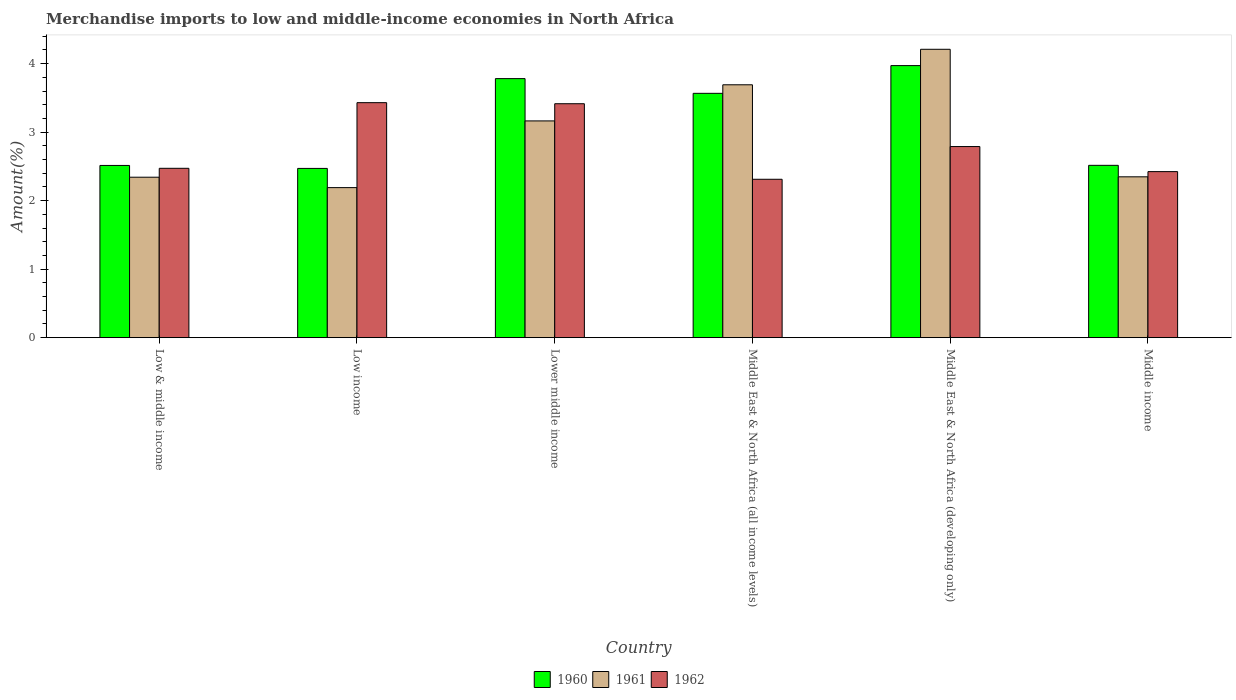Are the number of bars on each tick of the X-axis equal?
Ensure brevity in your answer.  Yes. What is the label of the 2nd group of bars from the left?
Your answer should be compact. Low income. In how many cases, is the number of bars for a given country not equal to the number of legend labels?
Provide a succinct answer. 0. What is the percentage of amount earned from merchandise imports in 1962 in Low income?
Offer a terse response. 3.43. Across all countries, what is the maximum percentage of amount earned from merchandise imports in 1960?
Offer a terse response. 3.97. Across all countries, what is the minimum percentage of amount earned from merchandise imports in 1962?
Give a very brief answer. 2.31. In which country was the percentage of amount earned from merchandise imports in 1960 maximum?
Provide a succinct answer. Middle East & North Africa (developing only). In which country was the percentage of amount earned from merchandise imports in 1962 minimum?
Keep it short and to the point. Middle East & North Africa (all income levels). What is the total percentage of amount earned from merchandise imports in 1962 in the graph?
Provide a short and direct response. 16.84. What is the difference between the percentage of amount earned from merchandise imports in 1960 in Middle East & North Africa (developing only) and that in Middle income?
Give a very brief answer. 1.46. What is the difference between the percentage of amount earned from merchandise imports in 1962 in Low & middle income and the percentage of amount earned from merchandise imports in 1961 in Middle income?
Offer a terse response. 0.12. What is the average percentage of amount earned from merchandise imports in 1962 per country?
Your answer should be very brief. 2.81. What is the difference between the percentage of amount earned from merchandise imports of/in 1961 and percentage of amount earned from merchandise imports of/in 1962 in Middle East & North Africa (developing only)?
Offer a terse response. 1.42. What is the ratio of the percentage of amount earned from merchandise imports in 1961 in Low & middle income to that in Middle East & North Africa (all income levels)?
Your answer should be very brief. 0.63. Is the difference between the percentage of amount earned from merchandise imports in 1961 in Low income and Lower middle income greater than the difference between the percentage of amount earned from merchandise imports in 1962 in Low income and Lower middle income?
Offer a terse response. No. What is the difference between the highest and the second highest percentage of amount earned from merchandise imports in 1960?
Offer a very short reply. -0.19. What is the difference between the highest and the lowest percentage of amount earned from merchandise imports in 1960?
Provide a succinct answer. 1.5. Are all the bars in the graph horizontal?
Provide a short and direct response. No. What is the difference between two consecutive major ticks on the Y-axis?
Your response must be concise. 1. How are the legend labels stacked?
Your answer should be very brief. Horizontal. What is the title of the graph?
Make the answer very short. Merchandise imports to low and middle-income economies in North Africa. Does "2000" appear as one of the legend labels in the graph?
Offer a very short reply. No. What is the label or title of the X-axis?
Make the answer very short. Country. What is the label or title of the Y-axis?
Your answer should be very brief. Amount(%). What is the Amount(%) in 1960 in Low & middle income?
Make the answer very short. 2.51. What is the Amount(%) in 1961 in Low & middle income?
Offer a very short reply. 2.34. What is the Amount(%) of 1962 in Low & middle income?
Your response must be concise. 2.47. What is the Amount(%) in 1960 in Low income?
Offer a terse response. 2.47. What is the Amount(%) of 1961 in Low income?
Keep it short and to the point. 2.19. What is the Amount(%) in 1962 in Low income?
Your answer should be very brief. 3.43. What is the Amount(%) of 1960 in Lower middle income?
Offer a very short reply. 3.78. What is the Amount(%) of 1961 in Lower middle income?
Provide a succinct answer. 3.16. What is the Amount(%) in 1962 in Lower middle income?
Make the answer very short. 3.41. What is the Amount(%) in 1960 in Middle East & North Africa (all income levels)?
Offer a very short reply. 3.57. What is the Amount(%) of 1961 in Middle East & North Africa (all income levels)?
Provide a succinct answer. 3.69. What is the Amount(%) in 1962 in Middle East & North Africa (all income levels)?
Give a very brief answer. 2.31. What is the Amount(%) of 1960 in Middle East & North Africa (developing only)?
Offer a very short reply. 3.97. What is the Amount(%) of 1961 in Middle East & North Africa (developing only)?
Provide a short and direct response. 4.21. What is the Amount(%) of 1962 in Middle East & North Africa (developing only)?
Your response must be concise. 2.79. What is the Amount(%) in 1960 in Middle income?
Provide a succinct answer. 2.52. What is the Amount(%) of 1961 in Middle income?
Make the answer very short. 2.35. What is the Amount(%) in 1962 in Middle income?
Give a very brief answer. 2.42. Across all countries, what is the maximum Amount(%) in 1960?
Offer a terse response. 3.97. Across all countries, what is the maximum Amount(%) in 1961?
Provide a succinct answer. 4.21. Across all countries, what is the maximum Amount(%) of 1962?
Make the answer very short. 3.43. Across all countries, what is the minimum Amount(%) of 1960?
Your answer should be compact. 2.47. Across all countries, what is the minimum Amount(%) of 1961?
Keep it short and to the point. 2.19. Across all countries, what is the minimum Amount(%) in 1962?
Offer a very short reply. 2.31. What is the total Amount(%) in 1960 in the graph?
Make the answer very short. 18.82. What is the total Amount(%) in 1961 in the graph?
Offer a terse response. 17.94. What is the total Amount(%) of 1962 in the graph?
Make the answer very short. 16.84. What is the difference between the Amount(%) of 1960 in Low & middle income and that in Low income?
Offer a very short reply. 0.04. What is the difference between the Amount(%) in 1961 in Low & middle income and that in Low income?
Your response must be concise. 0.15. What is the difference between the Amount(%) in 1962 in Low & middle income and that in Low income?
Make the answer very short. -0.96. What is the difference between the Amount(%) in 1960 in Low & middle income and that in Lower middle income?
Make the answer very short. -1.27. What is the difference between the Amount(%) of 1961 in Low & middle income and that in Lower middle income?
Offer a very short reply. -0.82. What is the difference between the Amount(%) in 1962 in Low & middle income and that in Lower middle income?
Make the answer very short. -0.94. What is the difference between the Amount(%) in 1960 in Low & middle income and that in Middle East & North Africa (all income levels)?
Provide a short and direct response. -1.05. What is the difference between the Amount(%) in 1961 in Low & middle income and that in Middle East & North Africa (all income levels)?
Your answer should be compact. -1.35. What is the difference between the Amount(%) of 1962 in Low & middle income and that in Middle East & North Africa (all income levels)?
Offer a terse response. 0.16. What is the difference between the Amount(%) in 1960 in Low & middle income and that in Middle East & North Africa (developing only)?
Your answer should be compact. -1.46. What is the difference between the Amount(%) in 1961 in Low & middle income and that in Middle East & North Africa (developing only)?
Offer a terse response. -1.87. What is the difference between the Amount(%) of 1962 in Low & middle income and that in Middle East & North Africa (developing only)?
Offer a terse response. -0.32. What is the difference between the Amount(%) of 1960 in Low & middle income and that in Middle income?
Ensure brevity in your answer.  -0. What is the difference between the Amount(%) in 1961 in Low & middle income and that in Middle income?
Give a very brief answer. -0.01. What is the difference between the Amount(%) of 1962 in Low & middle income and that in Middle income?
Your answer should be compact. 0.05. What is the difference between the Amount(%) in 1960 in Low income and that in Lower middle income?
Provide a short and direct response. -1.31. What is the difference between the Amount(%) of 1961 in Low income and that in Lower middle income?
Offer a very short reply. -0.97. What is the difference between the Amount(%) of 1962 in Low income and that in Lower middle income?
Ensure brevity in your answer.  0.02. What is the difference between the Amount(%) in 1960 in Low income and that in Middle East & North Africa (all income levels)?
Provide a short and direct response. -1.1. What is the difference between the Amount(%) in 1961 in Low income and that in Middle East & North Africa (all income levels)?
Ensure brevity in your answer.  -1.5. What is the difference between the Amount(%) of 1962 in Low income and that in Middle East & North Africa (all income levels)?
Offer a very short reply. 1.12. What is the difference between the Amount(%) of 1960 in Low income and that in Middle East & North Africa (developing only)?
Your answer should be very brief. -1.5. What is the difference between the Amount(%) in 1961 in Low income and that in Middle East & North Africa (developing only)?
Ensure brevity in your answer.  -2.02. What is the difference between the Amount(%) in 1962 in Low income and that in Middle East & North Africa (developing only)?
Give a very brief answer. 0.64. What is the difference between the Amount(%) in 1960 in Low income and that in Middle income?
Your answer should be very brief. -0.04. What is the difference between the Amount(%) in 1961 in Low income and that in Middle income?
Offer a terse response. -0.16. What is the difference between the Amount(%) of 1962 in Low income and that in Middle income?
Your answer should be compact. 1.01. What is the difference between the Amount(%) of 1960 in Lower middle income and that in Middle East & North Africa (all income levels)?
Your answer should be very brief. 0.21. What is the difference between the Amount(%) in 1961 in Lower middle income and that in Middle East & North Africa (all income levels)?
Ensure brevity in your answer.  -0.53. What is the difference between the Amount(%) in 1962 in Lower middle income and that in Middle East & North Africa (all income levels)?
Your response must be concise. 1.1. What is the difference between the Amount(%) of 1960 in Lower middle income and that in Middle East & North Africa (developing only)?
Your answer should be compact. -0.19. What is the difference between the Amount(%) in 1961 in Lower middle income and that in Middle East & North Africa (developing only)?
Provide a short and direct response. -1.05. What is the difference between the Amount(%) of 1962 in Lower middle income and that in Middle East & North Africa (developing only)?
Your answer should be very brief. 0.63. What is the difference between the Amount(%) in 1960 in Lower middle income and that in Middle income?
Your response must be concise. 1.27. What is the difference between the Amount(%) of 1961 in Lower middle income and that in Middle income?
Make the answer very short. 0.82. What is the difference between the Amount(%) in 1962 in Lower middle income and that in Middle income?
Your answer should be compact. 0.99. What is the difference between the Amount(%) of 1960 in Middle East & North Africa (all income levels) and that in Middle East & North Africa (developing only)?
Your answer should be very brief. -0.4. What is the difference between the Amount(%) in 1961 in Middle East & North Africa (all income levels) and that in Middle East & North Africa (developing only)?
Keep it short and to the point. -0.52. What is the difference between the Amount(%) of 1962 in Middle East & North Africa (all income levels) and that in Middle East & North Africa (developing only)?
Offer a very short reply. -0.48. What is the difference between the Amount(%) in 1960 in Middle East & North Africa (all income levels) and that in Middle income?
Provide a short and direct response. 1.05. What is the difference between the Amount(%) in 1961 in Middle East & North Africa (all income levels) and that in Middle income?
Give a very brief answer. 1.34. What is the difference between the Amount(%) of 1962 in Middle East & North Africa (all income levels) and that in Middle income?
Keep it short and to the point. -0.11. What is the difference between the Amount(%) in 1960 in Middle East & North Africa (developing only) and that in Middle income?
Your answer should be very brief. 1.46. What is the difference between the Amount(%) in 1961 in Middle East & North Africa (developing only) and that in Middle income?
Provide a succinct answer. 1.86. What is the difference between the Amount(%) in 1962 in Middle East & North Africa (developing only) and that in Middle income?
Your answer should be very brief. 0.37. What is the difference between the Amount(%) of 1960 in Low & middle income and the Amount(%) of 1961 in Low income?
Your response must be concise. 0.32. What is the difference between the Amount(%) in 1960 in Low & middle income and the Amount(%) in 1962 in Low income?
Your answer should be very brief. -0.92. What is the difference between the Amount(%) of 1961 in Low & middle income and the Amount(%) of 1962 in Low income?
Your response must be concise. -1.09. What is the difference between the Amount(%) of 1960 in Low & middle income and the Amount(%) of 1961 in Lower middle income?
Offer a very short reply. -0.65. What is the difference between the Amount(%) in 1960 in Low & middle income and the Amount(%) in 1962 in Lower middle income?
Your answer should be compact. -0.9. What is the difference between the Amount(%) of 1961 in Low & middle income and the Amount(%) of 1962 in Lower middle income?
Offer a terse response. -1.07. What is the difference between the Amount(%) of 1960 in Low & middle income and the Amount(%) of 1961 in Middle East & North Africa (all income levels)?
Ensure brevity in your answer.  -1.18. What is the difference between the Amount(%) in 1960 in Low & middle income and the Amount(%) in 1962 in Middle East & North Africa (all income levels)?
Your answer should be compact. 0.2. What is the difference between the Amount(%) in 1961 in Low & middle income and the Amount(%) in 1962 in Middle East & North Africa (all income levels)?
Your answer should be very brief. 0.03. What is the difference between the Amount(%) in 1960 in Low & middle income and the Amount(%) in 1961 in Middle East & North Africa (developing only)?
Your response must be concise. -1.7. What is the difference between the Amount(%) in 1960 in Low & middle income and the Amount(%) in 1962 in Middle East & North Africa (developing only)?
Your answer should be compact. -0.28. What is the difference between the Amount(%) in 1961 in Low & middle income and the Amount(%) in 1962 in Middle East & North Africa (developing only)?
Keep it short and to the point. -0.45. What is the difference between the Amount(%) in 1960 in Low & middle income and the Amount(%) in 1961 in Middle income?
Offer a very short reply. 0.17. What is the difference between the Amount(%) in 1960 in Low & middle income and the Amount(%) in 1962 in Middle income?
Your response must be concise. 0.09. What is the difference between the Amount(%) of 1961 in Low & middle income and the Amount(%) of 1962 in Middle income?
Offer a terse response. -0.08. What is the difference between the Amount(%) of 1960 in Low income and the Amount(%) of 1961 in Lower middle income?
Your answer should be very brief. -0.69. What is the difference between the Amount(%) of 1960 in Low income and the Amount(%) of 1962 in Lower middle income?
Keep it short and to the point. -0.94. What is the difference between the Amount(%) in 1961 in Low income and the Amount(%) in 1962 in Lower middle income?
Provide a short and direct response. -1.22. What is the difference between the Amount(%) in 1960 in Low income and the Amount(%) in 1961 in Middle East & North Africa (all income levels)?
Provide a short and direct response. -1.22. What is the difference between the Amount(%) of 1960 in Low income and the Amount(%) of 1962 in Middle East & North Africa (all income levels)?
Give a very brief answer. 0.16. What is the difference between the Amount(%) of 1961 in Low income and the Amount(%) of 1962 in Middle East & North Africa (all income levels)?
Your response must be concise. -0.12. What is the difference between the Amount(%) of 1960 in Low income and the Amount(%) of 1961 in Middle East & North Africa (developing only)?
Give a very brief answer. -1.74. What is the difference between the Amount(%) of 1960 in Low income and the Amount(%) of 1962 in Middle East & North Africa (developing only)?
Your answer should be compact. -0.32. What is the difference between the Amount(%) of 1961 in Low income and the Amount(%) of 1962 in Middle East & North Africa (developing only)?
Your response must be concise. -0.6. What is the difference between the Amount(%) of 1960 in Low income and the Amount(%) of 1961 in Middle income?
Your answer should be very brief. 0.12. What is the difference between the Amount(%) in 1960 in Low income and the Amount(%) in 1962 in Middle income?
Provide a short and direct response. 0.05. What is the difference between the Amount(%) in 1961 in Low income and the Amount(%) in 1962 in Middle income?
Keep it short and to the point. -0.23. What is the difference between the Amount(%) in 1960 in Lower middle income and the Amount(%) in 1961 in Middle East & North Africa (all income levels)?
Give a very brief answer. 0.09. What is the difference between the Amount(%) of 1960 in Lower middle income and the Amount(%) of 1962 in Middle East & North Africa (all income levels)?
Ensure brevity in your answer.  1.47. What is the difference between the Amount(%) of 1961 in Lower middle income and the Amount(%) of 1962 in Middle East & North Africa (all income levels)?
Your response must be concise. 0.85. What is the difference between the Amount(%) in 1960 in Lower middle income and the Amount(%) in 1961 in Middle East & North Africa (developing only)?
Offer a very short reply. -0.43. What is the difference between the Amount(%) of 1960 in Lower middle income and the Amount(%) of 1962 in Middle East & North Africa (developing only)?
Your answer should be very brief. 0.99. What is the difference between the Amount(%) in 1961 in Lower middle income and the Amount(%) in 1962 in Middle East & North Africa (developing only)?
Keep it short and to the point. 0.37. What is the difference between the Amount(%) in 1960 in Lower middle income and the Amount(%) in 1961 in Middle income?
Ensure brevity in your answer.  1.43. What is the difference between the Amount(%) in 1960 in Lower middle income and the Amount(%) in 1962 in Middle income?
Offer a very short reply. 1.36. What is the difference between the Amount(%) of 1961 in Lower middle income and the Amount(%) of 1962 in Middle income?
Ensure brevity in your answer.  0.74. What is the difference between the Amount(%) in 1960 in Middle East & North Africa (all income levels) and the Amount(%) in 1961 in Middle East & North Africa (developing only)?
Ensure brevity in your answer.  -0.64. What is the difference between the Amount(%) in 1960 in Middle East & North Africa (all income levels) and the Amount(%) in 1962 in Middle East & North Africa (developing only)?
Keep it short and to the point. 0.78. What is the difference between the Amount(%) in 1961 in Middle East & North Africa (all income levels) and the Amount(%) in 1962 in Middle East & North Africa (developing only)?
Provide a short and direct response. 0.9. What is the difference between the Amount(%) of 1960 in Middle East & North Africa (all income levels) and the Amount(%) of 1961 in Middle income?
Keep it short and to the point. 1.22. What is the difference between the Amount(%) in 1960 in Middle East & North Africa (all income levels) and the Amount(%) in 1962 in Middle income?
Ensure brevity in your answer.  1.14. What is the difference between the Amount(%) of 1961 in Middle East & North Africa (all income levels) and the Amount(%) of 1962 in Middle income?
Your response must be concise. 1.27. What is the difference between the Amount(%) in 1960 in Middle East & North Africa (developing only) and the Amount(%) in 1961 in Middle income?
Your answer should be compact. 1.62. What is the difference between the Amount(%) of 1960 in Middle East & North Africa (developing only) and the Amount(%) of 1962 in Middle income?
Offer a very short reply. 1.55. What is the difference between the Amount(%) of 1961 in Middle East & North Africa (developing only) and the Amount(%) of 1962 in Middle income?
Your response must be concise. 1.79. What is the average Amount(%) in 1960 per country?
Your answer should be compact. 3.14. What is the average Amount(%) of 1961 per country?
Provide a succinct answer. 2.99. What is the average Amount(%) of 1962 per country?
Give a very brief answer. 2.81. What is the difference between the Amount(%) in 1960 and Amount(%) in 1961 in Low & middle income?
Ensure brevity in your answer.  0.17. What is the difference between the Amount(%) of 1960 and Amount(%) of 1962 in Low & middle income?
Your response must be concise. 0.04. What is the difference between the Amount(%) of 1961 and Amount(%) of 1962 in Low & middle income?
Ensure brevity in your answer.  -0.13. What is the difference between the Amount(%) of 1960 and Amount(%) of 1961 in Low income?
Offer a very short reply. 0.28. What is the difference between the Amount(%) in 1960 and Amount(%) in 1962 in Low income?
Give a very brief answer. -0.96. What is the difference between the Amount(%) in 1961 and Amount(%) in 1962 in Low income?
Ensure brevity in your answer.  -1.24. What is the difference between the Amount(%) of 1960 and Amount(%) of 1961 in Lower middle income?
Provide a short and direct response. 0.62. What is the difference between the Amount(%) of 1960 and Amount(%) of 1962 in Lower middle income?
Your answer should be compact. 0.37. What is the difference between the Amount(%) in 1961 and Amount(%) in 1962 in Lower middle income?
Ensure brevity in your answer.  -0.25. What is the difference between the Amount(%) of 1960 and Amount(%) of 1961 in Middle East & North Africa (all income levels)?
Make the answer very short. -0.12. What is the difference between the Amount(%) of 1960 and Amount(%) of 1962 in Middle East & North Africa (all income levels)?
Keep it short and to the point. 1.25. What is the difference between the Amount(%) in 1961 and Amount(%) in 1962 in Middle East & North Africa (all income levels)?
Your answer should be very brief. 1.38. What is the difference between the Amount(%) of 1960 and Amount(%) of 1961 in Middle East & North Africa (developing only)?
Provide a short and direct response. -0.24. What is the difference between the Amount(%) of 1960 and Amount(%) of 1962 in Middle East & North Africa (developing only)?
Your response must be concise. 1.18. What is the difference between the Amount(%) of 1961 and Amount(%) of 1962 in Middle East & North Africa (developing only)?
Provide a succinct answer. 1.42. What is the difference between the Amount(%) of 1960 and Amount(%) of 1961 in Middle income?
Ensure brevity in your answer.  0.17. What is the difference between the Amount(%) of 1960 and Amount(%) of 1962 in Middle income?
Give a very brief answer. 0.09. What is the difference between the Amount(%) in 1961 and Amount(%) in 1962 in Middle income?
Provide a short and direct response. -0.08. What is the ratio of the Amount(%) in 1960 in Low & middle income to that in Low income?
Give a very brief answer. 1.02. What is the ratio of the Amount(%) of 1961 in Low & middle income to that in Low income?
Offer a terse response. 1.07. What is the ratio of the Amount(%) in 1962 in Low & middle income to that in Low income?
Ensure brevity in your answer.  0.72. What is the ratio of the Amount(%) of 1960 in Low & middle income to that in Lower middle income?
Your answer should be very brief. 0.66. What is the ratio of the Amount(%) in 1961 in Low & middle income to that in Lower middle income?
Ensure brevity in your answer.  0.74. What is the ratio of the Amount(%) in 1962 in Low & middle income to that in Lower middle income?
Provide a short and direct response. 0.72. What is the ratio of the Amount(%) of 1960 in Low & middle income to that in Middle East & North Africa (all income levels)?
Offer a terse response. 0.7. What is the ratio of the Amount(%) of 1961 in Low & middle income to that in Middle East & North Africa (all income levels)?
Your answer should be compact. 0.63. What is the ratio of the Amount(%) in 1962 in Low & middle income to that in Middle East & North Africa (all income levels)?
Provide a succinct answer. 1.07. What is the ratio of the Amount(%) in 1960 in Low & middle income to that in Middle East & North Africa (developing only)?
Give a very brief answer. 0.63. What is the ratio of the Amount(%) of 1961 in Low & middle income to that in Middle East & North Africa (developing only)?
Ensure brevity in your answer.  0.56. What is the ratio of the Amount(%) in 1962 in Low & middle income to that in Middle East & North Africa (developing only)?
Ensure brevity in your answer.  0.89. What is the ratio of the Amount(%) in 1960 in Low & middle income to that in Middle income?
Keep it short and to the point. 1. What is the ratio of the Amount(%) in 1961 in Low & middle income to that in Middle income?
Your response must be concise. 1. What is the ratio of the Amount(%) of 1962 in Low & middle income to that in Middle income?
Your answer should be very brief. 1.02. What is the ratio of the Amount(%) in 1960 in Low income to that in Lower middle income?
Offer a terse response. 0.65. What is the ratio of the Amount(%) in 1961 in Low income to that in Lower middle income?
Provide a short and direct response. 0.69. What is the ratio of the Amount(%) in 1962 in Low income to that in Lower middle income?
Make the answer very short. 1. What is the ratio of the Amount(%) in 1960 in Low income to that in Middle East & North Africa (all income levels)?
Give a very brief answer. 0.69. What is the ratio of the Amount(%) in 1961 in Low income to that in Middle East & North Africa (all income levels)?
Make the answer very short. 0.59. What is the ratio of the Amount(%) of 1962 in Low income to that in Middle East & North Africa (all income levels)?
Give a very brief answer. 1.48. What is the ratio of the Amount(%) of 1960 in Low income to that in Middle East & North Africa (developing only)?
Your response must be concise. 0.62. What is the ratio of the Amount(%) of 1961 in Low income to that in Middle East & North Africa (developing only)?
Make the answer very short. 0.52. What is the ratio of the Amount(%) of 1962 in Low income to that in Middle East & North Africa (developing only)?
Provide a short and direct response. 1.23. What is the ratio of the Amount(%) of 1960 in Low income to that in Middle income?
Provide a short and direct response. 0.98. What is the ratio of the Amount(%) in 1961 in Low income to that in Middle income?
Your response must be concise. 0.93. What is the ratio of the Amount(%) in 1962 in Low income to that in Middle income?
Give a very brief answer. 1.42. What is the ratio of the Amount(%) of 1960 in Lower middle income to that in Middle East & North Africa (all income levels)?
Give a very brief answer. 1.06. What is the ratio of the Amount(%) in 1961 in Lower middle income to that in Middle East & North Africa (all income levels)?
Your answer should be very brief. 0.86. What is the ratio of the Amount(%) of 1962 in Lower middle income to that in Middle East & North Africa (all income levels)?
Provide a succinct answer. 1.48. What is the ratio of the Amount(%) of 1960 in Lower middle income to that in Middle East & North Africa (developing only)?
Ensure brevity in your answer.  0.95. What is the ratio of the Amount(%) of 1961 in Lower middle income to that in Middle East & North Africa (developing only)?
Your answer should be very brief. 0.75. What is the ratio of the Amount(%) of 1962 in Lower middle income to that in Middle East & North Africa (developing only)?
Offer a terse response. 1.22. What is the ratio of the Amount(%) of 1960 in Lower middle income to that in Middle income?
Make the answer very short. 1.5. What is the ratio of the Amount(%) in 1961 in Lower middle income to that in Middle income?
Make the answer very short. 1.35. What is the ratio of the Amount(%) in 1962 in Lower middle income to that in Middle income?
Ensure brevity in your answer.  1.41. What is the ratio of the Amount(%) in 1960 in Middle East & North Africa (all income levels) to that in Middle East & North Africa (developing only)?
Keep it short and to the point. 0.9. What is the ratio of the Amount(%) of 1961 in Middle East & North Africa (all income levels) to that in Middle East & North Africa (developing only)?
Give a very brief answer. 0.88. What is the ratio of the Amount(%) of 1962 in Middle East & North Africa (all income levels) to that in Middle East & North Africa (developing only)?
Give a very brief answer. 0.83. What is the ratio of the Amount(%) in 1960 in Middle East & North Africa (all income levels) to that in Middle income?
Provide a succinct answer. 1.42. What is the ratio of the Amount(%) of 1961 in Middle East & North Africa (all income levels) to that in Middle income?
Offer a terse response. 1.57. What is the ratio of the Amount(%) in 1962 in Middle East & North Africa (all income levels) to that in Middle income?
Provide a short and direct response. 0.95. What is the ratio of the Amount(%) of 1960 in Middle East & North Africa (developing only) to that in Middle income?
Keep it short and to the point. 1.58. What is the ratio of the Amount(%) of 1961 in Middle East & North Africa (developing only) to that in Middle income?
Keep it short and to the point. 1.79. What is the ratio of the Amount(%) in 1962 in Middle East & North Africa (developing only) to that in Middle income?
Your response must be concise. 1.15. What is the difference between the highest and the second highest Amount(%) in 1960?
Make the answer very short. 0.19. What is the difference between the highest and the second highest Amount(%) in 1961?
Provide a succinct answer. 0.52. What is the difference between the highest and the second highest Amount(%) of 1962?
Your response must be concise. 0.02. What is the difference between the highest and the lowest Amount(%) in 1960?
Provide a succinct answer. 1.5. What is the difference between the highest and the lowest Amount(%) of 1961?
Provide a short and direct response. 2.02. What is the difference between the highest and the lowest Amount(%) in 1962?
Ensure brevity in your answer.  1.12. 